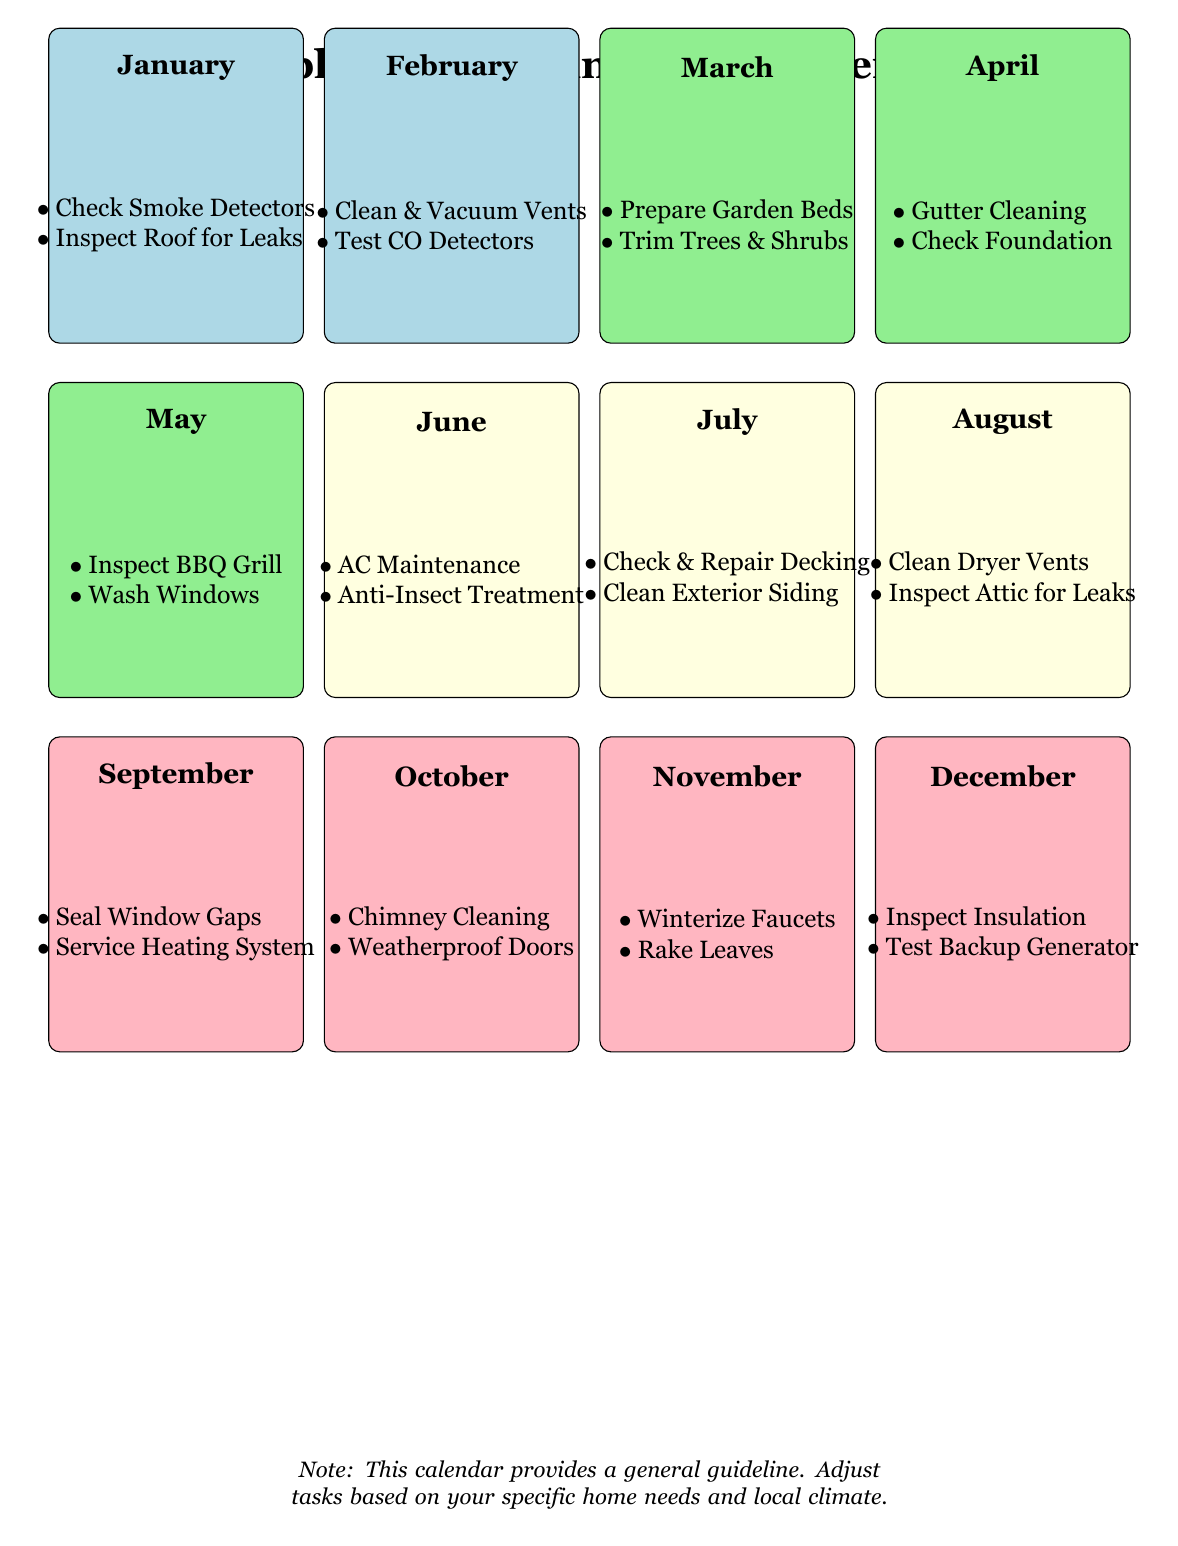What tasks should be performed in January? In January, the diagram lists the following maintenance tasks: Check Smoke Detectors and Inspect Roof for Leaks. This information is found in the section dedicated to January, clearly outlining the responsibilities for the month.
Answer: Check Smoke Detectors, Inspect Roof for Leaks How many seasonal categories are represented in the calendar? The calendar divides the tasks into four seasonal categories: Winter (January, February, March), Spring (April, May, June), Summer (July, August, September), and Fall (October, November, December). Counting these categories gives us the answer.
Answer: 4 Which month involves checking the heating system? In the calendar, the month of October includes the task to Service Heating System. This information is situated under the section for October, making it easy to locate.
Answer: October What are two tasks outlined for September? The tasks for September include: Seal Window Gaps and Service Heating System. Both tasks are specified in the checklist for September.
Answer: Seal Window Gaps, Service Heating System Which month suggests cleaning dryer vents? The month of August is indicated for the task of Clean Dryer Vents along with Inspect Attic for Leaks, as listed in that section of the calendar.
Answer: August What task comes before winterizing faucets? The task of Winterize Faucets appears in December. However, prior to that, the November section states the tasks: Chimney Cleaning and Weatherproof Doors. Thus, it is determined that Chimney Cleaning comes before Winterize Faucets.
Answer: Chimney Cleaning How many tasks are suggested for each month? Each month in the calendar outlines two specific maintenance tasks, providing a structured approach to home maintenance throughout the year. This consistency can be observed by counting the number of tasks listed under each monthly section.
Answer: 2 Which months are dedicated to garden preparation tasks? The months focused on garden preparation tasks are March and April. In March, the tasks include Prepare Garden Beds, and in April, Gutter Cleaning is highlighted. This can be confirmed by looking at the listings for those months.
Answer: March, April 